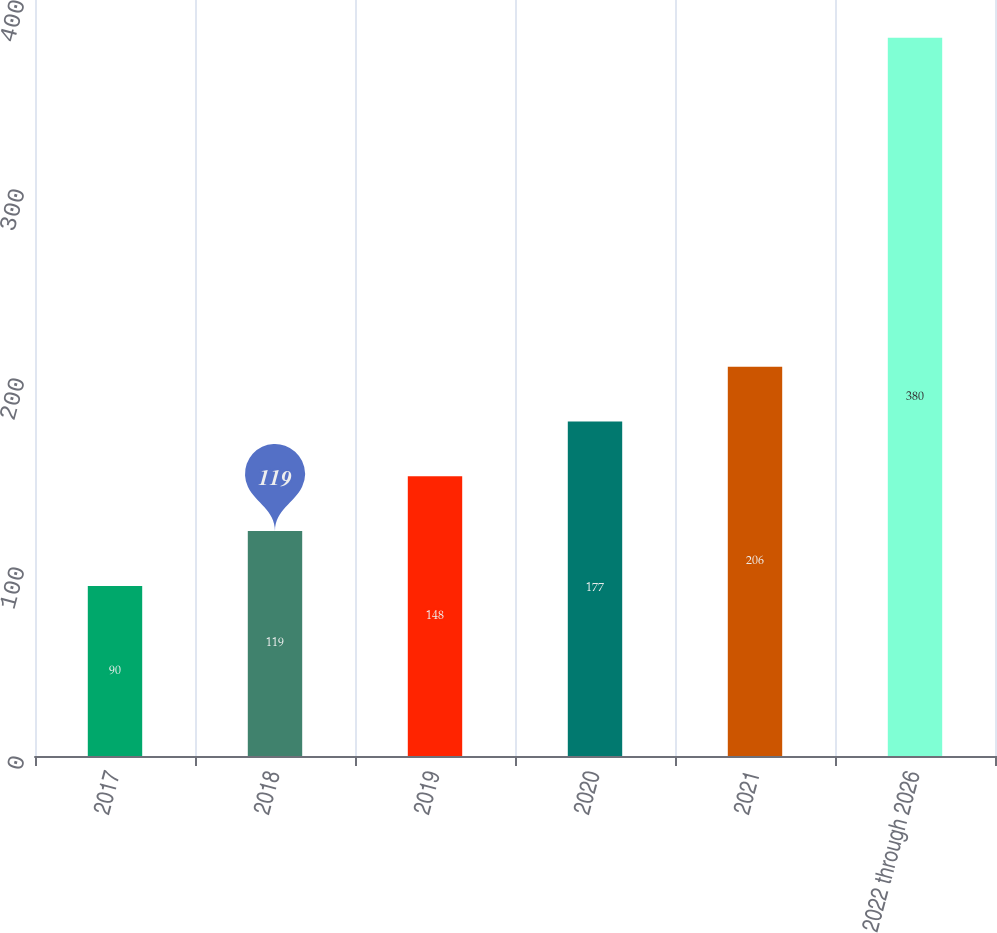Convert chart to OTSL. <chart><loc_0><loc_0><loc_500><loc_500><bar_chart><fcel>2017<fcel>2018<fcel>2019<fcel>2020<fcel>2021<fcel>2022 through 2026<nl><fcel>90<fcel>119<fcel>148<fcel>177<fcel>206<fcel>380<nl></chart> 